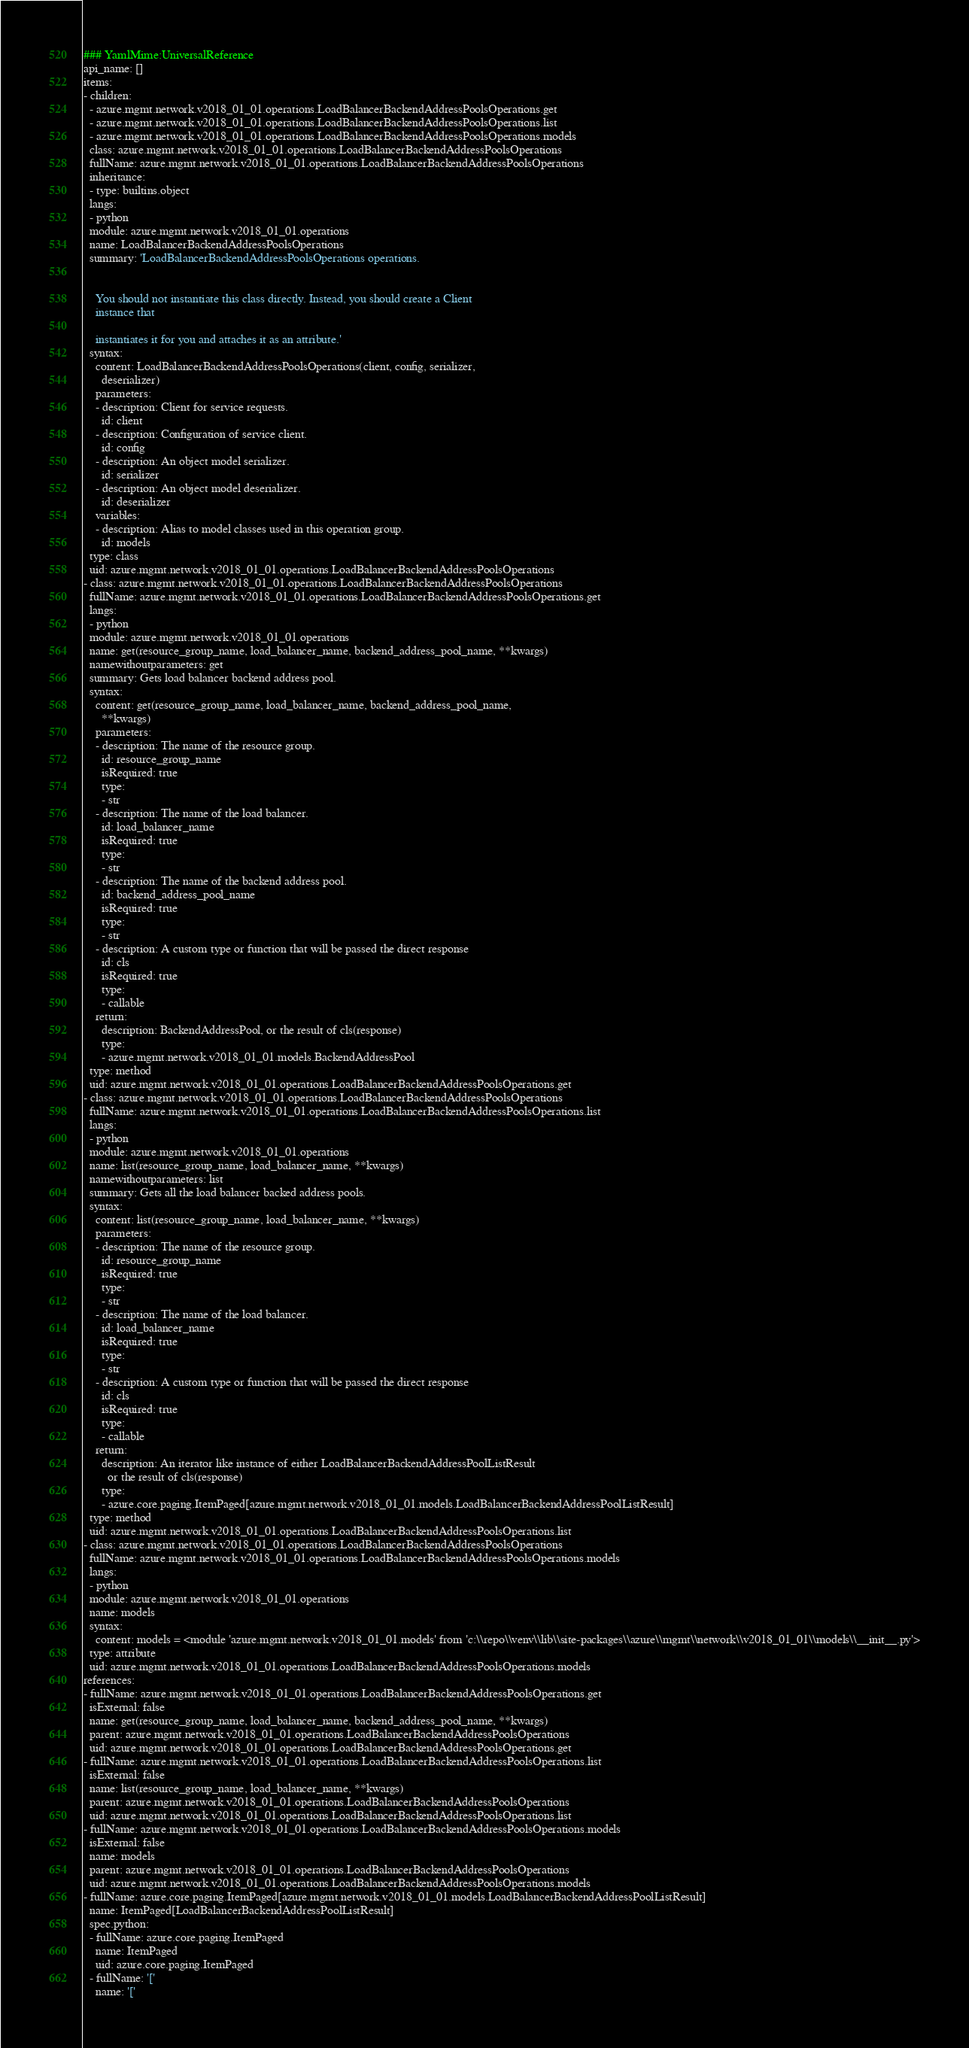Convert code to text. <code><loc_0><loc_0><loc_500><loc_500><_YAML_>### YamlMime:UniversalReference
api_name: []
items:
- children:
  - azure.mgmt.network.v2018_01_01.operations.LoadBalancerBackendAddressPoolsOperations.get
  - azure.mgmt.network.v2018_01_01.operations.LoadBalancerBackendAddressPoolsOperations.list
  - azure.mgmt.network.v2018_01_01.operations.LoadBalancerBackendAddressPoolsOperations.models
  class: azure.mgmt.network.v2018_01_01.operations.LoadBalancerBackendAddressPoolsOperations
  fullName: azure.mgmt.network.v2018_01_01.operations.LoadBalancerBackendAddressPoolsOperations
  inheritance:
  - type: builtins.object
  langs:
  - python
  module: azure.mgmt.network.v2018_01_01.operations
  name: LoadBalancerBackendAddressPoolsOperations
  summary: 'LoadBalancerBackendAddressPoolsOperations operations.


    You should not instantiate this class directly. Instead, you should create a Client
    instance that

    instantiates it for you and attaches it as an attribute.'
  syntax:
    content: LoadBalancerBackendAddressPoolsOperations(client, config, serializer,
      deserializer)
    parameters:
    - description: Client for service requests.
      id: client
    - description: Configuration of service client.
      id: config
    - description: An object model serializer.
      id: serializer
    - description: An object model deserializer.
      id: deserializer
    variables:
    - description: Alias to model classes used in this operation group.
      id: models
  type: class
  uid: azure.mgmt.network.v2018_01_01.operations.LoadBalancerBackendAddressPoolsOperations
- class: azure.mgmt.network.v2018_01_01.operations.LoadBalancerBackendAddressPoolsOperations
  fullName: azure.mgmt.network.v2018_01_01.operations.LoadBalancerBackendAddressPoolsOperations.get
  langs:
  - python
  module: azure.mgmt.network.v2018_01_01.operations
  name: get(resource_group_name, load_balancer_name, backend_address_pool_name, **kwargs)
  namewithoutparameters: get
  summary: Gets load balancer backend address pool.
  syntax:
    content: get(resource_group_name, load_balancer_name, backend_address_pool_name,
      **kwargs)
    parameters:
    - description: The name of the resource group.
      id: resource_group_name
      isRequired: true
      type:
      - str
    - description: The name of the load balancer.
      id: load_balancer_name
      isRequired: true
      type:
      - str
    - description: The name of the backend address pool.
      id: backend_address_pool_name
      isRequired: true
      type:
      - str
    - description: A custom type or function that will be passed the direct response
      id: cls
      isRequired: true
      type:
      - callable
    return:
      description: BackendAddressPool, or the result of cls(response)
      type:
      - azure.mgmt.network.v2018_01_01.models.BackendAddressPool
  type: method
  uid: azure.mgmt.network.v2018_01_01.operations.LoadBalancerBackendAddressPoolsOperations.get
- class: azure.mgmt.network.v2018_01_01.operations.LoadBalancerBackendAddressPoolsOperations
  fullName: azure.mgmt.network.v2018_01_01.operations.LoadBalancerBackendAddressPoolsOperations.list
  langs:
  - python
  module: azure.mgmt.network.v2018_01_01.operations
  name: list(resource_group_name, load_balancer_name, **kwargs)
  namewithoutparameters: list
  summary: Gets all the load balancer backed address pools.
  syntax:
    content: list(resource_group_name, load_balancer_name, **kwargs)
    parameters:
    - description: The name of the resource group.
      id: resource_group_name
      isRequired: true
      type:
      - str
    - description: The name of the load balancer.
      id: load_balancer_name
      isRequired: true
      type:
      - str
    - description: A custom type or function that will be passed the direct response
      id: cls
      isRequired: true
      type:
      - callable
    return:
      description: An iterator like instance of either LoadBalancerBackendAddressPoolListResult
        or the result of cls(response)
      type:
      - azure.core.paging.ItemPaged[azure.mgmt.network.v2018_01_01.models.LoadBalancerBackendAddressPoolListResult]
  type: method
  uid: azure.mgmt.network.v2018_01_01.operations.LoadBalancerBackendAddressPoolsOperations.list
- class: azure.mgmt.network.v2018_01_01.operations.LoadBalancerBackendAddressPoolsOperations
  fullName: azure.mgmt.network.v2018_01_01.operations.LoadBalancerBackendAddressPoolsOperations.models
  langs:
  - python
  module: azure.mgmt.network.v2018_01_01.operations
  name: models
  syntax:
    content: models = <module 'azure.mgmt.network.v2018_01_01.models' from 'c:\\repo\\venv\\lib\\site-packages\\azure\\mgmt\\network\\v2018_01_01\\models\\__init__.py'>
  type: attribute
  uid: azure.mgmt.network.v2018_01_01.operations.LoadBalancerBackendAddressPoolsOperations.models
references:
- fullName: azure.mgmt.network.v2018_01_01.operations.LoadBalancerBackendAddressPoolsOperations.get
  isExternal: false
  name: get(resource_group_name, load_balancer_name, backend_address_pool_name, **kwargs)
  parent: azure.mgmt.network.v2018_01_01.operations.LoadBalancerBackendAddressPoolsOperations
  uid: azure.mgmt.network.v2018_01_01.operations.LoadBalancerBackendAddressPoolsOperations.get
- fullName: azure.mgmt.network.v2018_01_01.operations.LoadBalancerBackendAddressPoolsOperations.list
  isExternal: false
  name: list(resource_group_name, load_balancer_name, **kwargs)
  parent: azure.mgmt.network.v2018_01_01.operations.LoadBalancerBackendAddressPoolsOperations
  uid: azure.mgmt.network.v2018_01_01.operations.LoadBalancerBackendAddressPoolsOperations.list
- fullName: azure.mgmt.network.v2018_01_01.operations.LoadBalancerBackendAddressPoolsOperations.models
  isExternal: false
  name: models
  parent: azure.mgmt.network.v2018_01_01.operations.LoadBalancerBackendAddressPoolsOperations
  uid: azure.mgmt.network.v2018_01_01.operations.LoadBalancerBackendAddressPoolsOperations.models
- fullName: azure.core.paging.ItemPaged[azure.mgmt.network.v2018_01_01.models.LoadBalancerBackendAddressPoolListResult]
  name: ItemPaged[LoadBalancerBackendAddressPoolListResult]
  spec.python:
  - fullName: azure.core.paging.ItemPaged
    name: ItemPaged
    uid: azure.core.paging.ItemPaged
  - fullName: '['
    name: '['</code> 